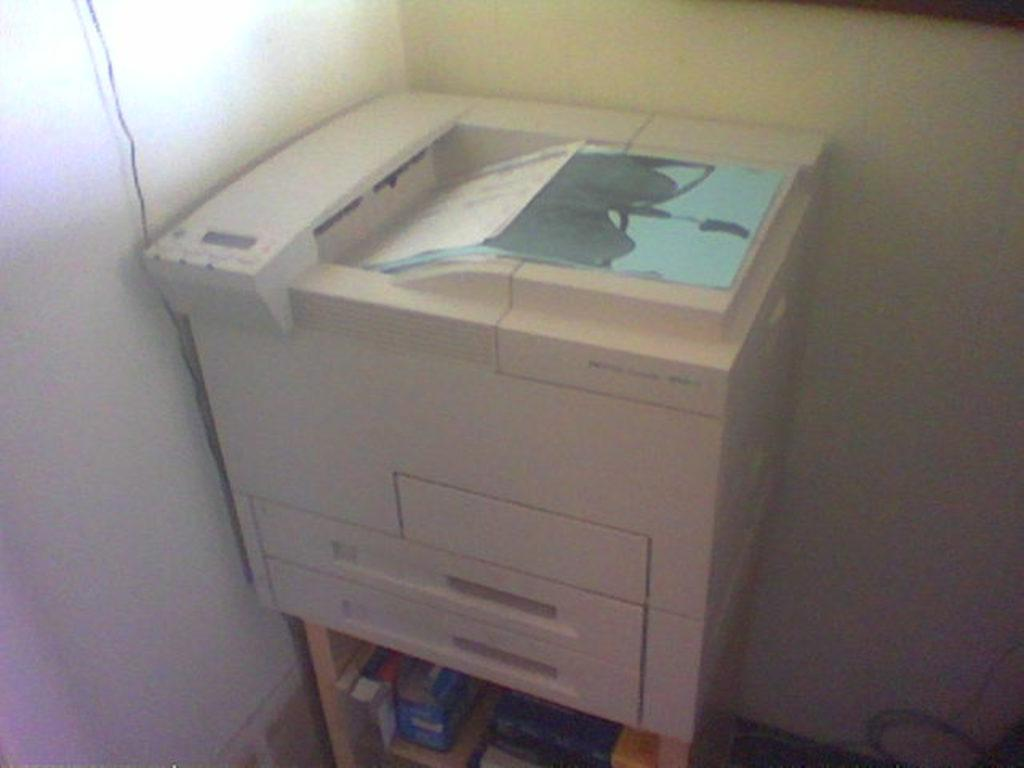What is the main object in the image? There is a printing machine in the image. What else can be seen in the image besides the printing machine? There are books visible in the image. What type of structure might the walls in the image belong to? The walls in the image might belong to a room or building. How many clocks are hanging on the walls in the image? There are no clocks visible in the image. What type of yoke is being used to hold the books in the image? There is no yoke present in the image; the books are simply placed on a surface. 